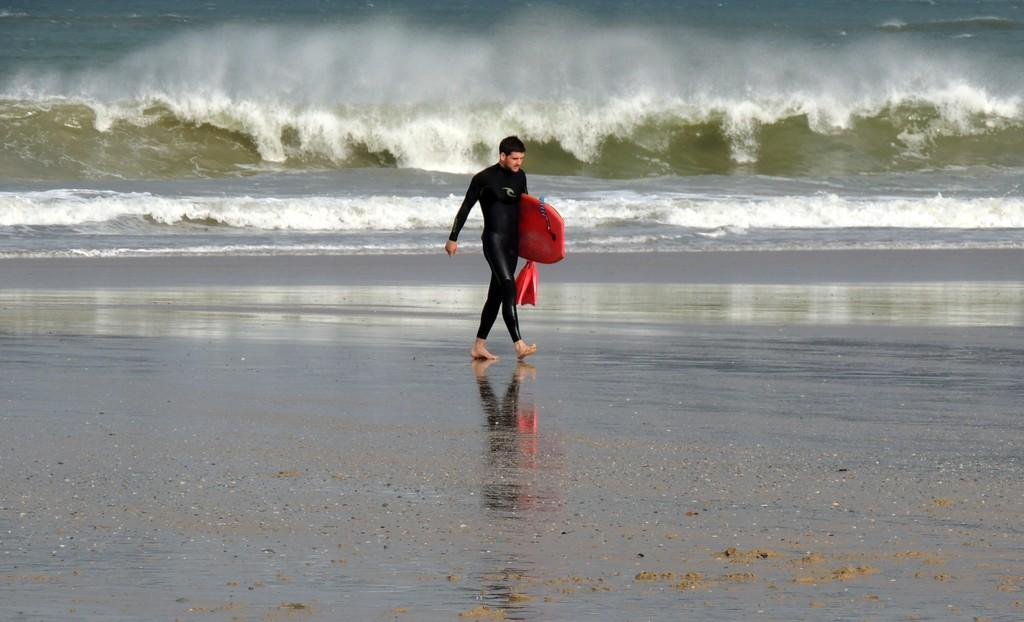Who is present in the image? There is a man in the image. What is the man holding in the image? The man is holding a surfboard. What can be seen in the background of the image? There is an ocean in the background of the image. What is the condition of the water in the image? Waves of water are visible in the image. What type of comfort can be seen being provided by the man to the ghost in the image? There is no ghost present in the image, and the man is not providing any comfort to anyone. 